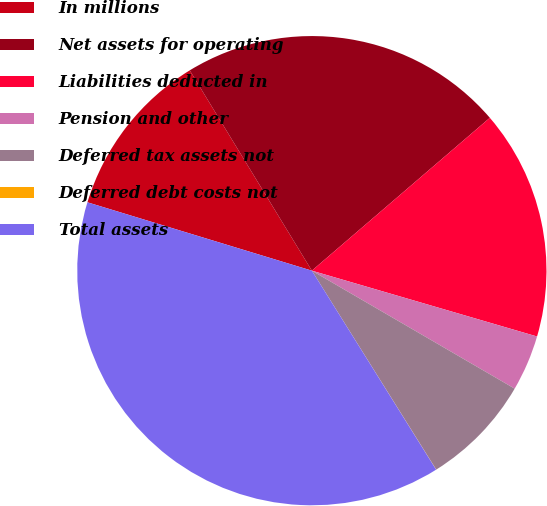Convert chart. <chart><loc_0><loc_0><loc_500><loc_500><pie_chart><fcel>In millions<fcel>Net assets for operating<fcel>Liabilities deducted in<fcel>Pension and other<fcel>Deferred tax assets not<fcel>Deferred debt costs not<fcel>Total assets<nl><fcel>11.58%<fcel>22.42%<fcel>15.82%<fcel>3.86%<fcel>7.72%<fcel>0.01%<fcel>38.59%<nl></chart> 